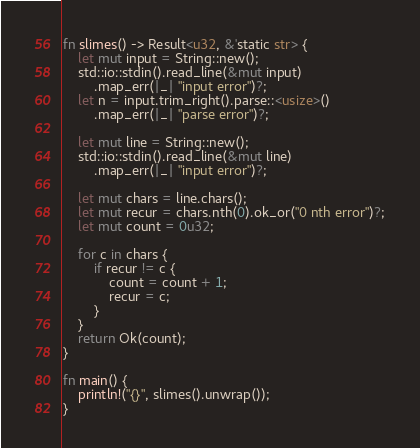<code> <loc_0><loc_0><loc_500><loc_500><_Rust_>fn slimes() -> Result<u32, &'static str> {
    let mut input = String::new();
    std::io::stdin().read_line(&mut input)
        .map_err(|_| "input error")?;
    let n = input.trim_right().parse::<usize>()
        .map_err(|_| "parse error")?;

    let mut line = String::new();
    std::io::stdin().read_line(&mut line)
        .map_err(|_| "input error")?;

    let mut chars = line.chars();
    let mut recur = chars.nth(0).ok_or("0 nth error")?;
    let mut count = 0u32;

    for c in chars {
        if recur != c {
            count = count + 1;
            recur = c;
        }
    }
    return Ok(count);
}

fn main() {
    println!("{}", slimes().unwrap());
}
</code> 